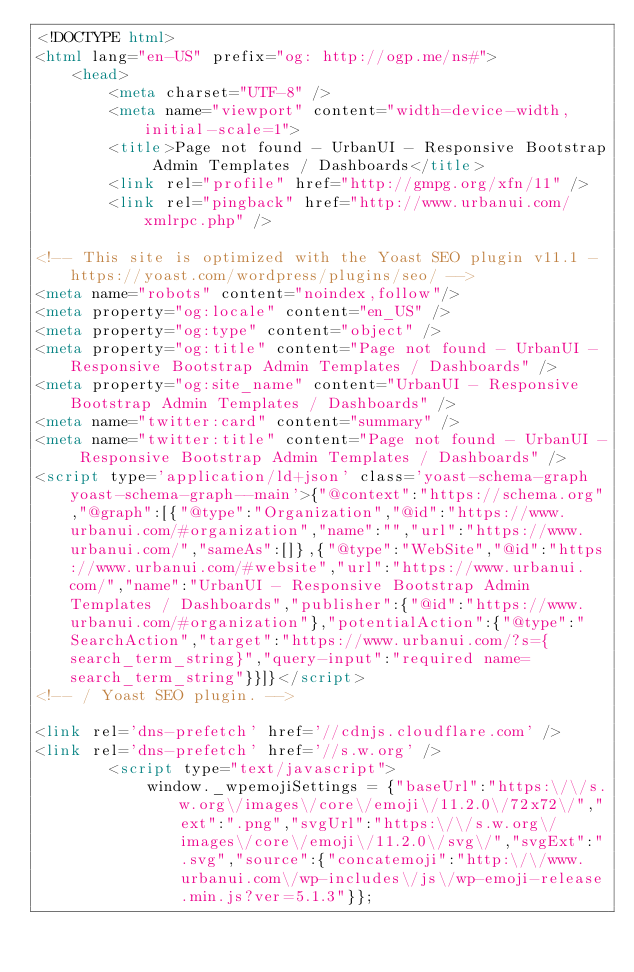<code> <loc_0><loc_0><loc_500><loc_500><_HTML_><!DOCTYPE html>
<html lang="en-US" prefix="og: http://ogp.me/ns#">
    <head>
        <meta charset="UTF-8" />
        <meta name="viewport" content="width=device-width, initial-scale=1">
        <title>Page not found - UrbanUI - Responsive Bootstrap Admin Templates / Dashboards</title>
        <link rel="profile" href="http://gmpg.org/xfn/11" />
        <link rel="pingback" href="http://www.urbanui.com/xmlrpc.php" />
                
<!-- This site is optimized with the Yoast SEO plugin v11.1 - https://yoast.com/wordpress/plugins/seo/ -->
<meta name="robots" content="noindex,follow"/>
<meta property="og:locale" content="en_US" />
<meta property="og:type" content="object" />
<meta property="og:title" content="Page not found - UrbanUI - Responsive Bootstrap Admin Templates / Dashboards" />
<meta property="og:site_name" content="UrbanUI - Responsive Bootstrap Admin Templates / Dashboards" />
<meta name="twitter:card" content="summary" />
<meta name="twitter:title" content="Page not found - UrbanUI - Responsive Bootstrap Admin Templates / Dashboards" />
<script type='application/ld+json' class='yoast-schema-graph yoast-schema-graph--main'>{"@context":"https://schema.org","@graph":[{"@type":"Organization","@id":"https://www.urbanui.com/#organization","name":"","url":"https://www.urbanui.com/","sameAs":[]},{"@type":"WebSite","@id":"https://www.urbanui.com/#website","url":"https://www.urbanui.com/","name":"UrbanUI - Responsive Bootstrap Admin Templates / Dashboards","publisher":{"@id":"https://www.urbanui.com/#organization"},"potentialAction":{"@type":"SearchAction","target":"https://www.urbanui.com/?s={search_term_string}","query-input":"required name=search_term_string"}}]}</script>
<!-- / Yoast SEO plugin. -->

<link rel='dns-prefetch' href='//cdnjs.cloudflare.com' />
<link rel='dns-prefetch' href='//s.w.org' />
		<script type="text/javascript">
			window._wpemojiSettings = {"baseUrl":"https:\/\/s.w.org\/images\/core\/emoji\/11.2.0\/72x72\/","ext":".png","svgUrl":"https:\/\/s.w.org\/images\/core\/emoji\/11.2.0\/svg\/","svgExt":".svg","source":{"concatemoji":"http:\/\/www.urbanui.com\/wp-includes\/js\/wp-emoji-release.min.js?ver=5.1.3"}};</code> 